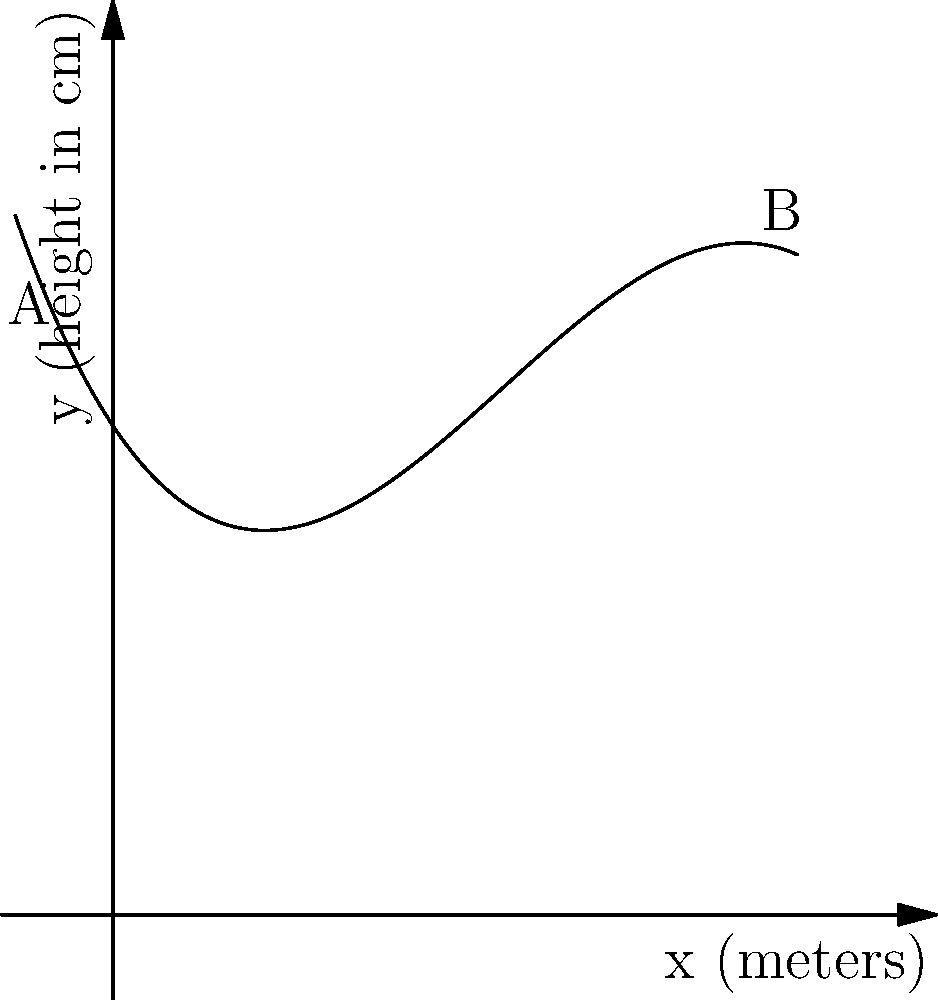A budget-friendly motorcycle manufacturer wants to design an aerodynamic fairing for their new model. The shape of the fairing can be approximated by the polynomial function $f(x) = -0.05x^3 + 0.6x^2 - 1.5x + 5$, where $x$ is the distance from the front of the fairing in meters, and $f(x)$ is the height of the fairing in centimeters. What is the maximum height of the fairing, and at what distance from the front does it occur? To find the maximum height of the fairing, we need to find the maximum value of the function $f(x)$. This occurs where the derivative $f'(x)$ is equal to zero.

Step 1: Find the derivative of $f(x)$
$f'(x) = -0.15x^2 + 1.2x - 1.5$

Step 2: Set $f'(x) = 0$ and solve for $x$
$-0.15x^2 + 1.2x - 1.5 = 0$

This is a quadratic equation. We can solve it using the quadratic formula:
$x = \frac{-b \pm \sqrt{b^2 - 4ac}}{2a}$

Where $a = -0.15$, $b = 1.2$, and $c = -1.5$

$x = \frac{-1.2 \pm \sqrt{1.2^2 - 4(-0.15)(-1.5)}}{2(-0.15)}$

$x \approx 2$ or $x \approx 5$

Step 3: Check which $x$ value gives the maximum
$f(2) \approx 6.1$ cm
$f(5) \approx 5.625$ cm

Therefore, the maximum occurs at $x = 2$ meters.

Step 4: Calculate the maximum height
The maximum height is $f(2) \approx 6.1$ cm.
Answer: Maximum height: 6.1 cm at 2 meters from the front 